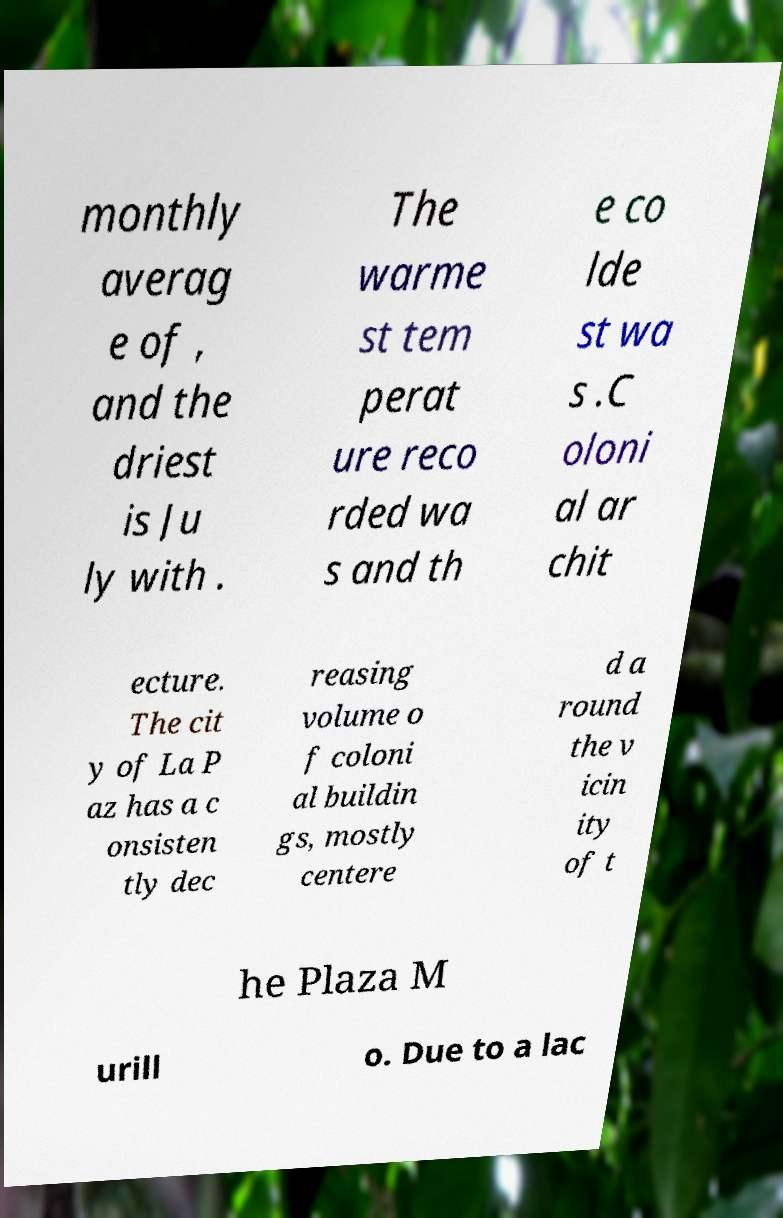What messages or text are displayed in this image? I need them in a readable, typed format. monthly averag e of , and the driest is Ju ly with . The warme st tem perat ure reco rded wa s and th e co lde st wa s .C oloni al ar chit ecture. The cit y of La P az has a c onsisten tly dec reasing volume o f coloni al buildin gs, mostly centere d a round the v icin ity of t he Plaza M urill o. Due to a lac 